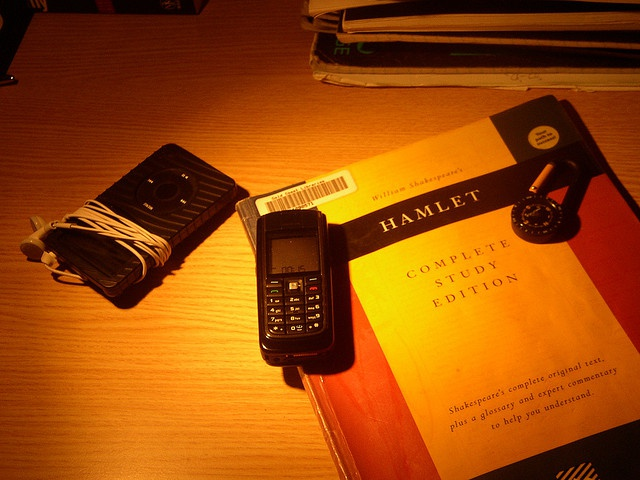Describe the objects in this image and their specific colors. I can see book in black, red, orange, and maroon tones, book in black, brown, and maroon tones, cell phone in black, maroon, and brown tones, and book in maroon and black tones in this image. 